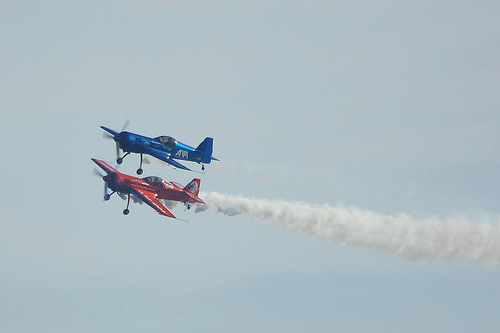What maneuvers are the airplanes performing? The airplanes appear to be engaged in an aerobatic performance, potentially illustrating maneuvers such as rolls or formation flying. 